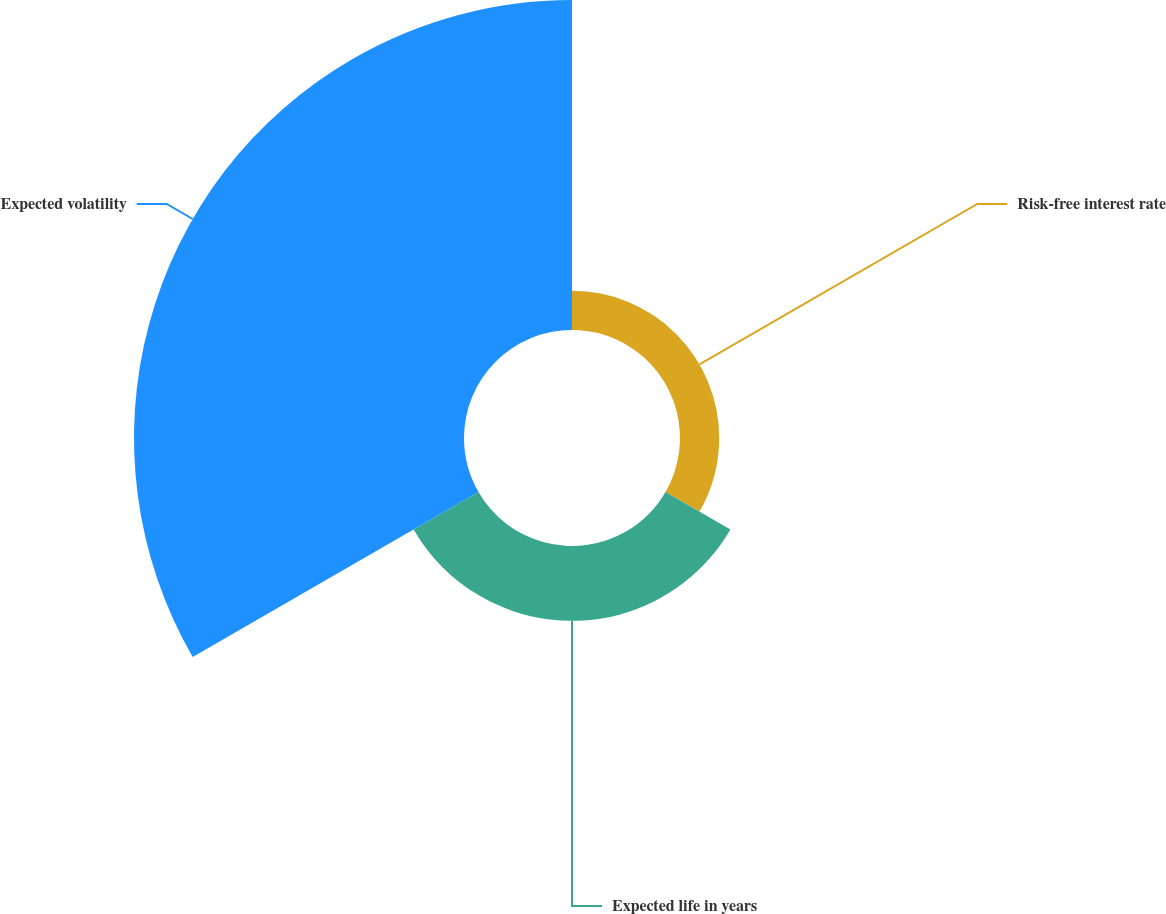Convert chart. <chart><loc_0><loc_0><loc_500><loc_500><pie_chart><fcel>Risk-free interest rate<fcel>Expected life in years<fcel>Expected volatility<nl><fcel>8.83%<fcel>16.86%<fcel>74.31%<nl></chart> 